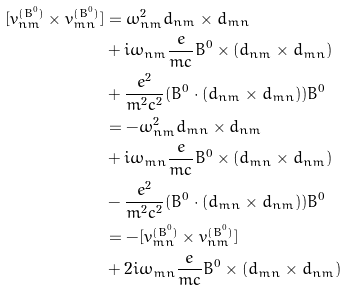Convert formula to latex. <formula><loc_0><loc_0><loc_500><loc_500>[ { v ^ { ( B ^ { 0 } ) } _ { n m } } \times { v ^ { ( B ^ { 0 } ) } _ { m n } } ] & = \omega ^ { 2 } _ { n m } { d _ { n m } } \times { d _ { m n } } \\ & + i { \omega _ { n m } } \frac { e } { m c } B ^ { 0 } \times ( { d _ { n m } } \times { d _ { m n } } ) \\ & + \frac { e ^ { 2 } } { m ^ { 2 } c ^ { 2 } } ( B ^ { 0 } \cdot ( { d _ { n m } } \times { d _ { m n } } ) ) B ^ { 0 } \\ & = - \omega ^ { 2 } _ { n m } { d _ { m n } } \times { d _ { n m } } \\ & + i { \omega _ { m n } } \frac { e } { m c } B ^ { 0 } \times ( { d _ { m n } } \times { d _ { n m } } ) \\ & - \frac { e ^ { 2 } } { m ^ { 2 } c ^ { 2 } } ( B ^ { 0 } \cdot ( { d _ { m n } } \times { d _ { n m } } ) ) B ^ { 0 } \\ & = - [ { v ^ { ( B ^ { 0 } ) } _ { m n } } \times { v ^ { ( B ^ { 0 } ) } _ { n m } } ] \\ & + 2 i { \omega _ { m n } } \frac { e } { m c } B ^ { 0 } \times ( { d _ { m n } } \times { d _ { n m } } ) \\</formula> 